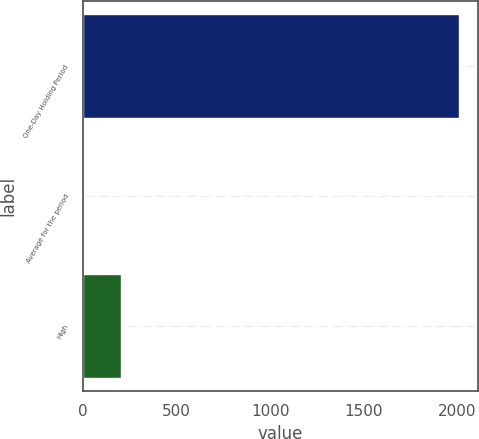Convert chart to OTSL. <chart><loc_0><loc_0><loc_500><loc_500><bar_chart><fcel>One-Day Holding Period<fcel>Average for the period<fcel>High<nl><fcel>2007<fcel>3<fcel>203.4<nl></chart> 